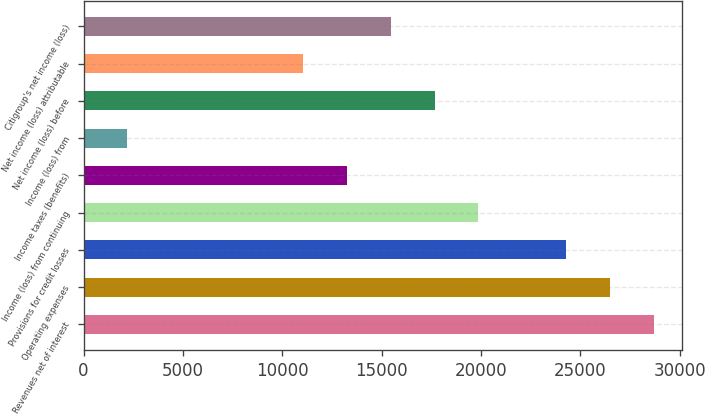Convert chart. <chart><loc_0><loc_0><loc_500><loc_500><bar_chart><fcel>Revenues net of interest<fcel>Operating expenses<fcel>Provisions for credit losses<fcel>Income (loss) from continuing<fcel>Income taxes (benefits)<fcel>Income (loss) from<fcel>Net income (loss) before<fcel>Net income (loss) attributable<fcel>Citigroup's net income (loss)<nl><fcel>28692.3<fcel>26485.2<fcel>24278.1<fcel>19863.9<fcel>13242.6<fcel>2207.18<fcel>17656.8<fcel>11035.5<fcel>15449.7<nl></chart> 